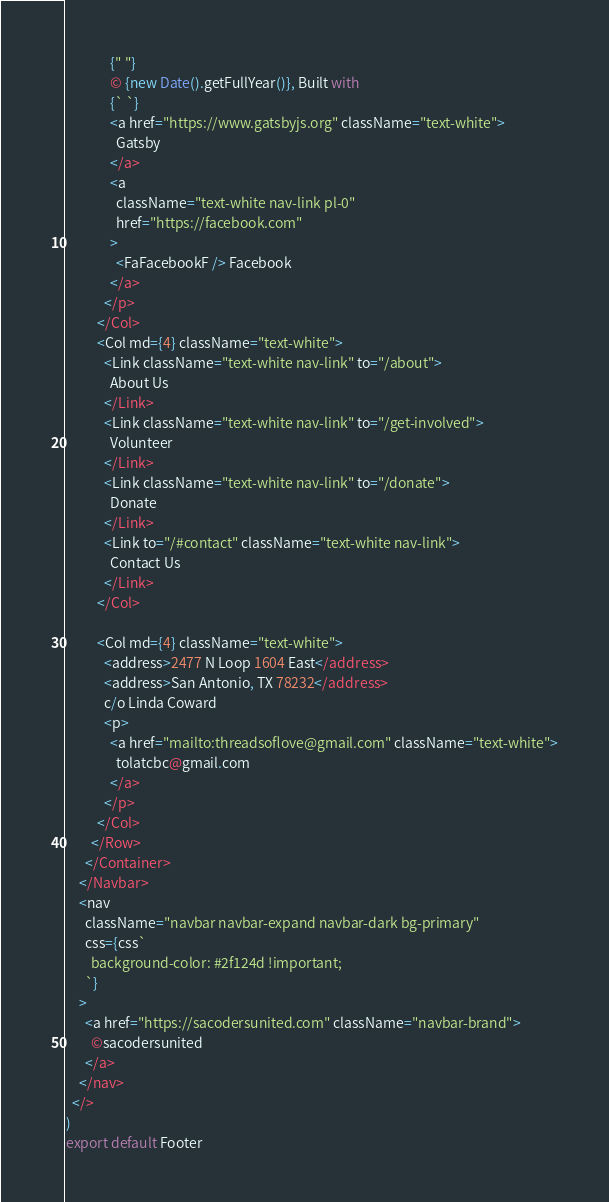Convert code to text. <code><loc_0><loc_0><loc_500><loc_500><_JavaScript_>              {" "}
              © {new Date().getFullYear()}, Built with
              {` `}
              <a href="https://www.gatsbyjs.org" className="text-white">
                Gatsby
              </a>
              <a
                className="text-white nav-link pl-0"
                href="https://facebook.com"
              >
                <FaFacebookF /> Facebook
              </a>
            </p>
          </Col>
          <Col md={4} className="text-white">
            <Link className="text-white nav-link" to="/about">
              About Us
            </Link>
            <Link className="text-white nav-link" to="/get-involved">
              Volunteer
            </Link>
            <Link className="text-white nav-link" to="/donate">
              Donate
            </Link>
            <Link to="/#contact" className="text-white nav-link">
              Contact Us
            </Link>
          </Col>

          <Col md={4} className="text-white">
            <address>2477 N Loop 1604 East</address>
            <address>San Antonio, TX 78232</address>
            c/o Linda Coward
            <p>
              <a href="mailto:threadsoflove@gmail.com" className="text-white">
                tolatcbc@gmail.com
              </a>
            </p>
          </Col>
        </Row>
      </Container>
    </Navbar>
    <nav
      className="navbar navbar-expand navbar-dark bg-primary"
      css={css`
        background-color: #2f124d !important;
      `}
    >
      <a href="https://sacodersunited.com" className="navbar-brand">
        ©sacodersunited
      </a>
    </nav>
  </>
)
export default Footer
</code> 